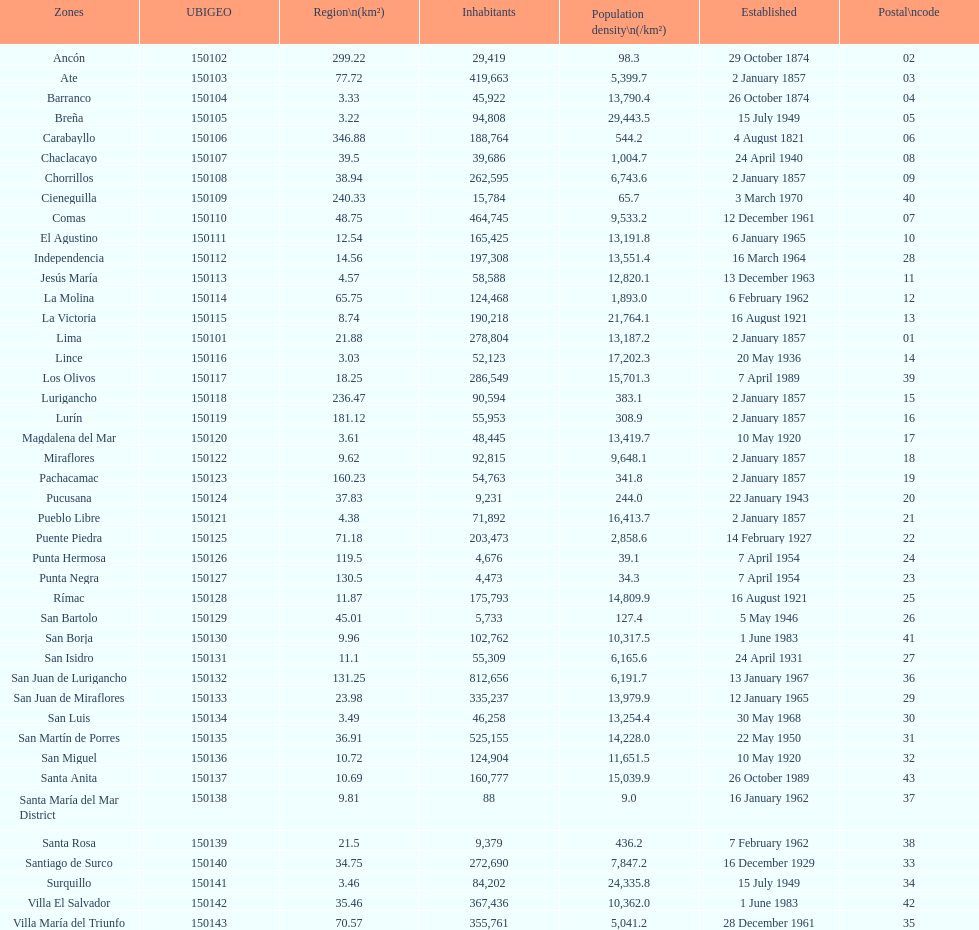Which district in this city has the greatest population? San Juan de Lurigancho. 